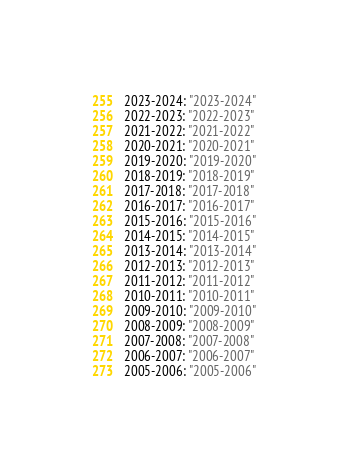<code> <loc_0><loc_0><loc_500><loc_500><_YAML_>2023-2024: "2023-2024"
2022-2023: "2022-2023"
2021-2022: "2021-2022"
2020-2021: "2020-2021"
2019-2020: "2019-2020"
2018-2019: "2018-2019"
2017-2018: "2017-2018"
2016-2017: "2016-2017"
2015-2016: "2015-2016"
2014-2015: "2014-2015"
2013-2014: "2013-2014"
2012-2013: "2012-2013"
2011-2012: "2011-2012"
2010-2011: "2010-2011"
2009-2010: "2009-2010"
2008-2009: "2008-2009"
2007-2008: "2007-2008"
2006-2007: "2006-2007"
2005-2006: "2005-2006"
</code> 